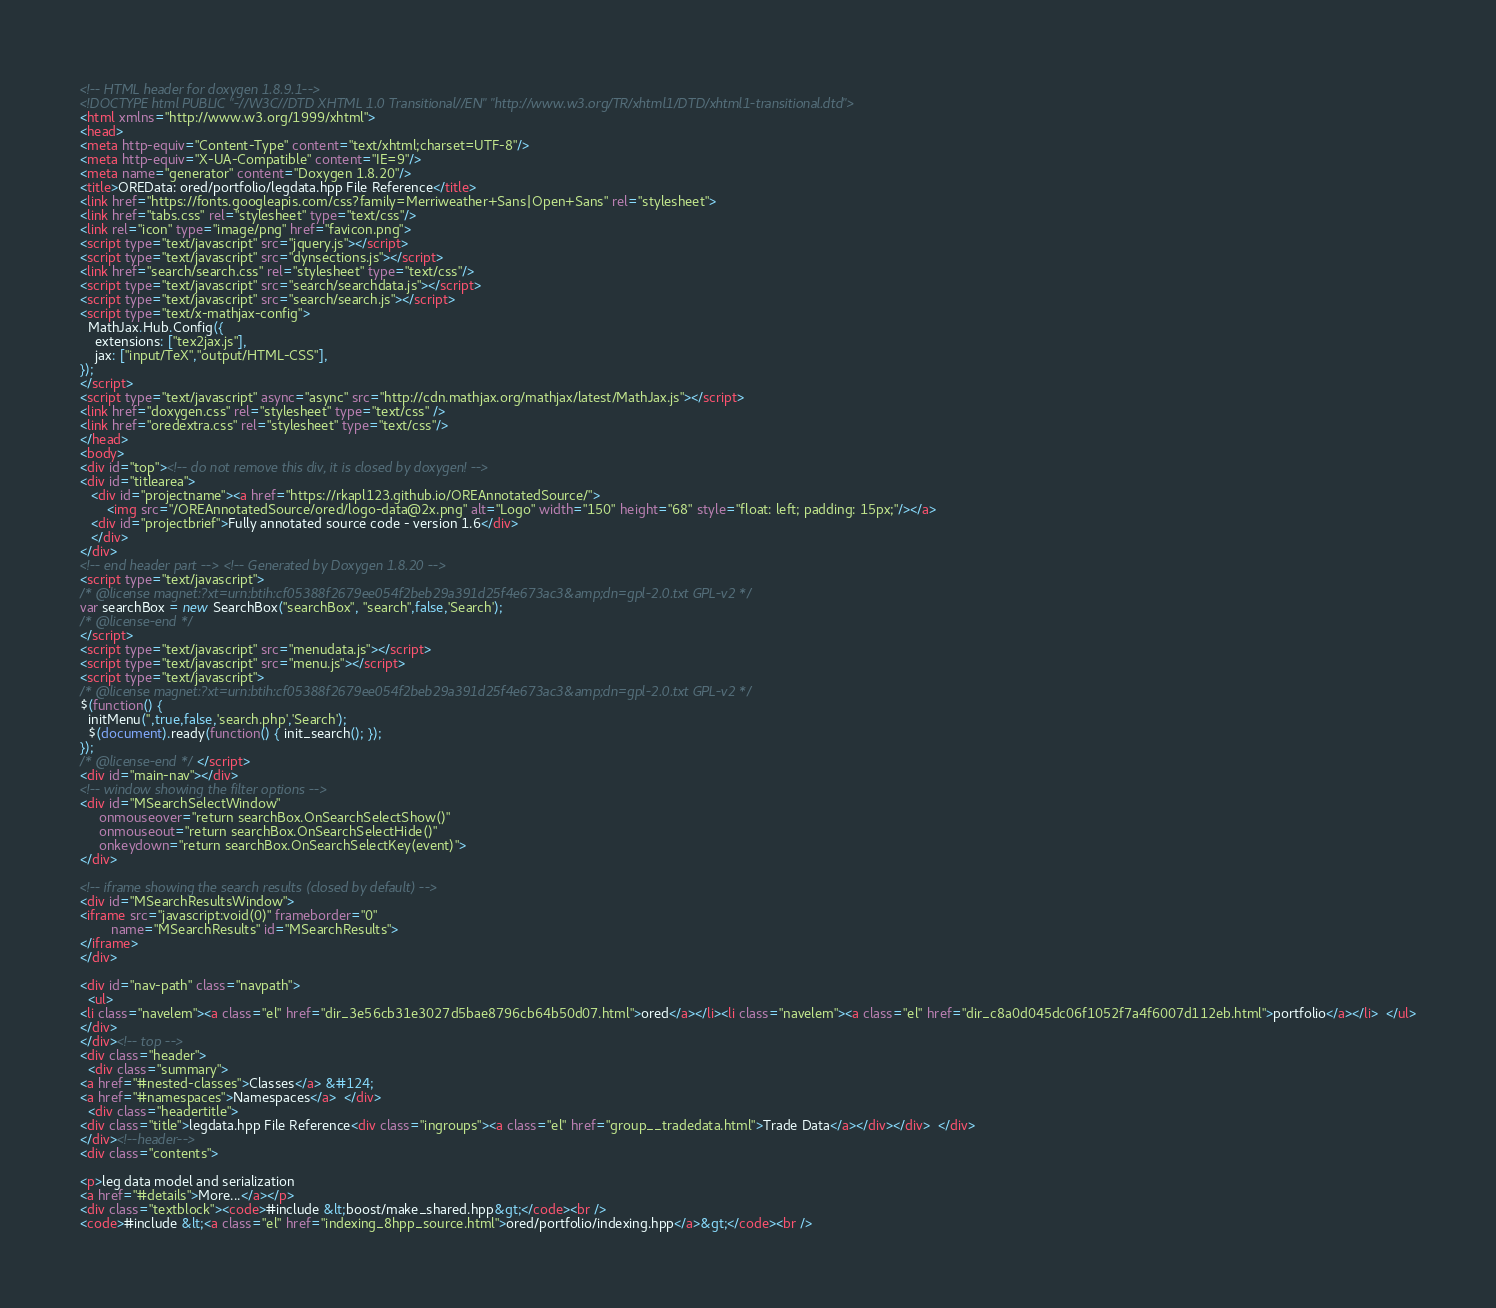<code> <loc_0><loc_0><loc_500><loc_500><_HTML_><!-- HTML header for doxygen 1.8.9.1-->
<!DOCTYPE html PUBLIC "-//W3C//DTD XHTML 1.0 Transitional//EN" "http://www.w3.org/TR/xhtml1/DTD/xhtml1-transitional.dtd">
<html xmlns="http://www.w3.org/1999/xhtml">
<head>
<meta http-equiv="Content-Type" content="text/xhtml;charset=UTF-8"/>
<meta http-equiv="X-UA-Compatible" content="IE=9"/>
<meta name="generator" content="Doxygen 1.8.20"/>
<title>OREData: ored/portfolio/legdata.hpp File Reference</title>
<link href="https://fonts.googleapis.com/css?family=Merriweather+Sans|Open+Sans" rel="stylesheet">
<link href="tabs.css" rel="stylesheet" type="text/css"/>
<link rel="icon" type="image/png" href="favicon.png">
<script type="text/javascript" src="jquery.js"></script>
<script type="text/javascript" src="dynsections.js"></script>
<link href="search/search.css" rel="stylesheet" type="text/css"/>
<script type="text/javascript" src="search/searchdata.js"></script>
<script type="text/javascript" src="search/search.js"></script>
<script type="text/x-mathjax-config">
  MathJax.Hub.Config({
    extensions: ["tex2jax.js"],
    jax: ["input/TeX","output/HTML-CSS"],
});
</script>
<script type="text/javascript" async="async" src="http://cdn.mathjax.org/mathjax/latest/MathJax.js"></script>
<link href="doxygen.css" rel="stylesheet" type="text/css" />
<link href="oredextra.css" rel="stylesheet" type="text/css"/>
</head>
<body>
<div id="top"><!-- do not remove this div, it is closed by doxygen! -->
<div id="titlearea">
   <div id="projectname"><a href="https://rkapl123.github.io/OREAnnotatedSource/">
       <img src="/OREAnnotatedSource/ored/logo-data@2x.png" alt="Logo" width="150" height="68" style="float: left; padding: 15px;"/></a>
   <div id="projectbrief">Fully annotated source code - version 1.6</div>
   </div>
</div>
<!-- end header part --><!-- Generated by Doxygen 1.8.20 -->
<script type="text/javascript">
/* @license magnet:?xt=urn:btih:cf05388f2679ee054f2beb29a391d25f4e673ac3&amp;dn=gpl-2.0.txt GPL-v2 */
var searchBox = new SearchBox("searchBox", "search",false,'Search');
/* @license-end */
</script>
<script type="text/javascript" src="menudata.js"></script>
<script type="text/javascript" src="menu.js"></script>
<script type="text/javascript">
/* @license magnet:?xt=urn:btih:cf05388f2679ee054f2beb29a391d25f4e673ac3&amp;dn=gpl-2.0.txt GPL-v2 */
$(function() {
  initMenu('',true,false,'search.php','Search');
  $(document).ready(function() { init_search(); });
});
/* @license-end */</script>
<div id="main-nav"></div>
<!-- window showing the filter options -->
<div id="MSearchSelectWindow"
     onmouseover="return searchBox.OnSearchSelectShow()"
     onmouseout="return searchBox.OnSearchSelectHide()"
     onkeydown="return searchBox.OnSearchSelectKey(event)">
</div>

<!-- iframe showing the search results (closed by default) -->
<div id="MSearchResultsWindow">
<iframe src="javascript:void(0)" frameborder="0" 
        name="MSearchResults" id="MSearchResults">
</iframe>
</div>

<div id="nav-path" class="navpath">
  <ul>
<li class="navelem"><a class="el" href="dir_3e56cb31e3027d5bae8796cb64b50d07.html">ored</a></li><li class="navelem"><a class="el" href="dir_c8a0d045dc06f1052f7a4f6007d112eb.html">portfolio</a></li>  </ul>
</div>
</div><!-- top -->
<div class="header">
  <div class="summary">
<a href="#nested-classes">Classes</a> &#124;
<a href="#namespaces">Namespaces</a>  </div>
  <div class="headertitle">
<div class="title">legdata.hpp File Reference<div class="ingroups"><a class="el" href="group__tradedata.html">Trade Data</a></div></div>  </div>
</div><!--header-->
<div class="contents">

<p>leg data model and serialization  
<a href="#details">More...</a></p>
<div class="textblock"><code>#include &lt;boost/make_shared.hpp&gt;</code><br />
<code>#include &lt;<a class="el" href="indexing_8hpp_source.html">ored/portfolio/indexing.hpp</a>&gt;</code><br /></code> 